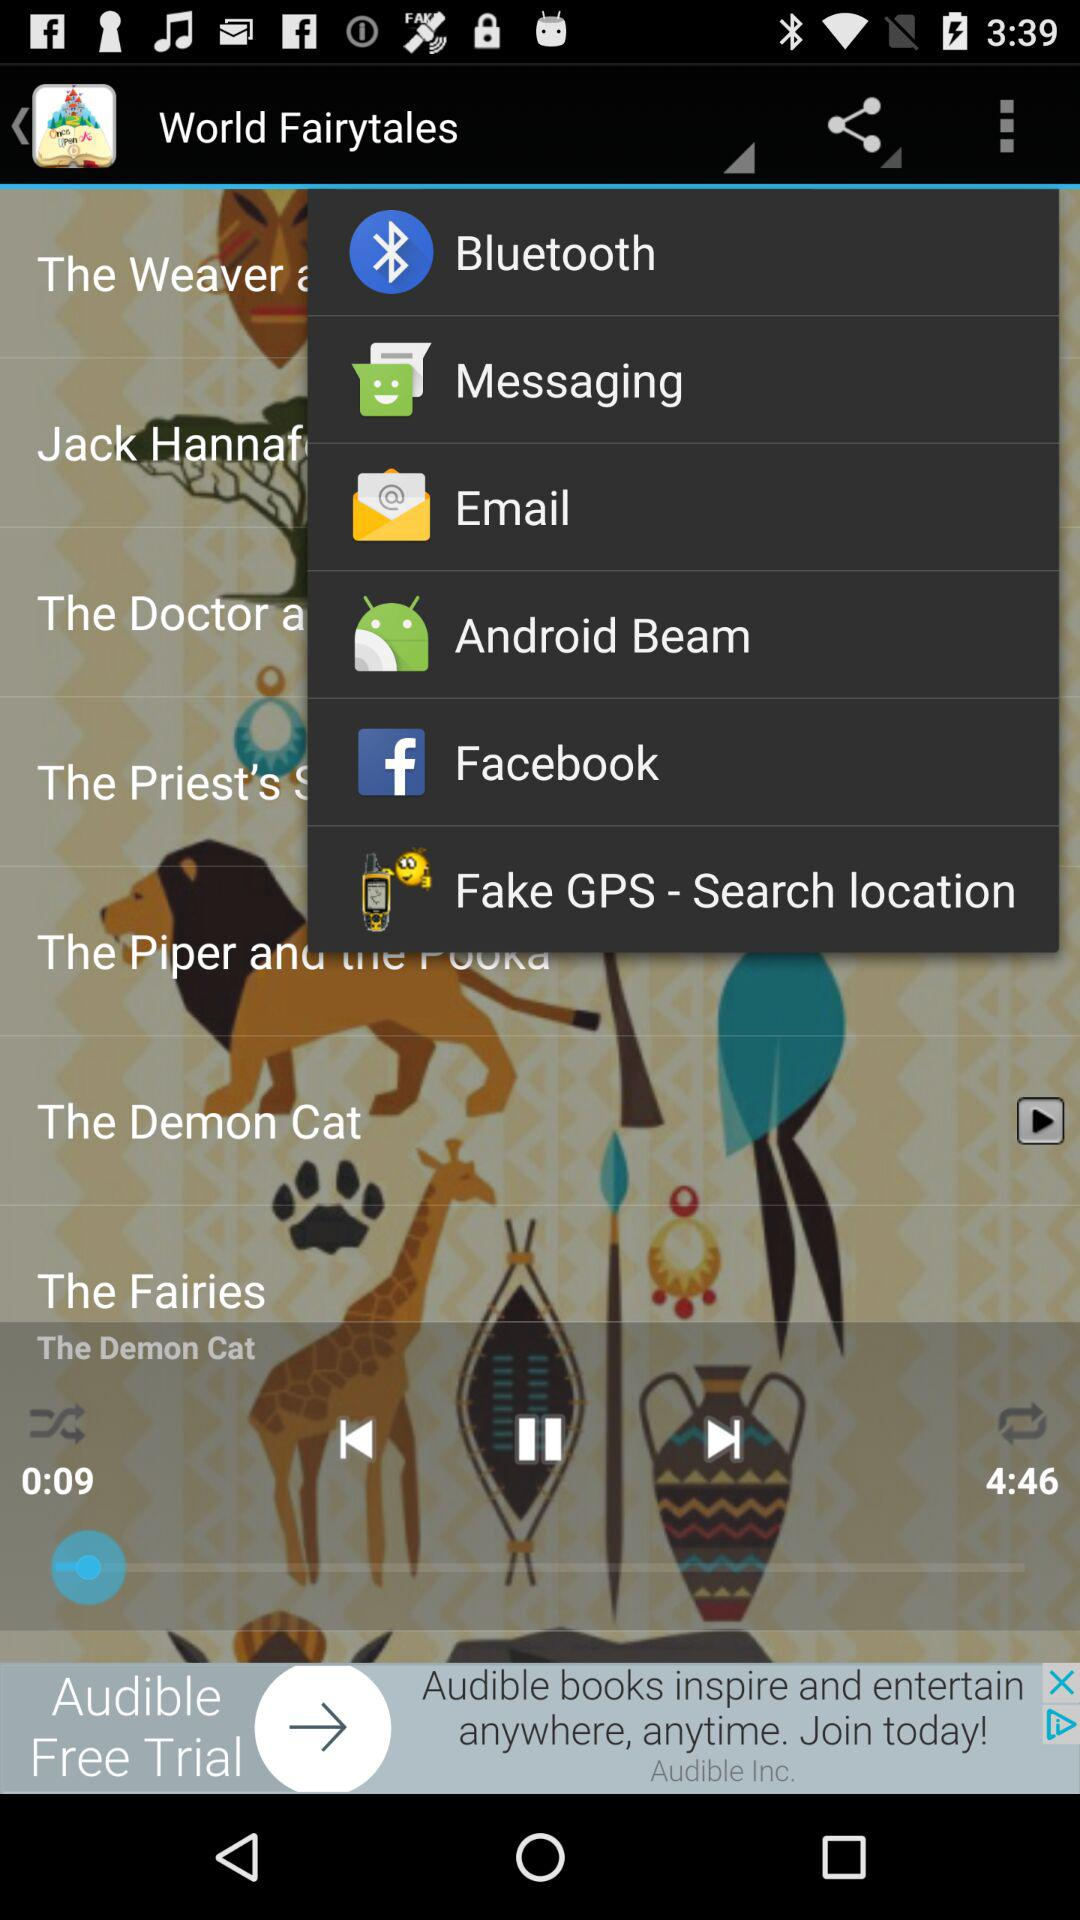How long has the audio been playing? The audio has been playing for 9 seconds. 